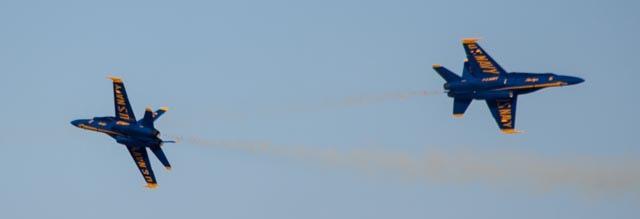How many planes are in the sky?
Give a very brief answer. 2. How many planes?
Give a very brief answer. 2. How many airplanes are in the picture?
Give a very brief answer. 2. How many people are traveling?
Give a very brief answer. 0. 